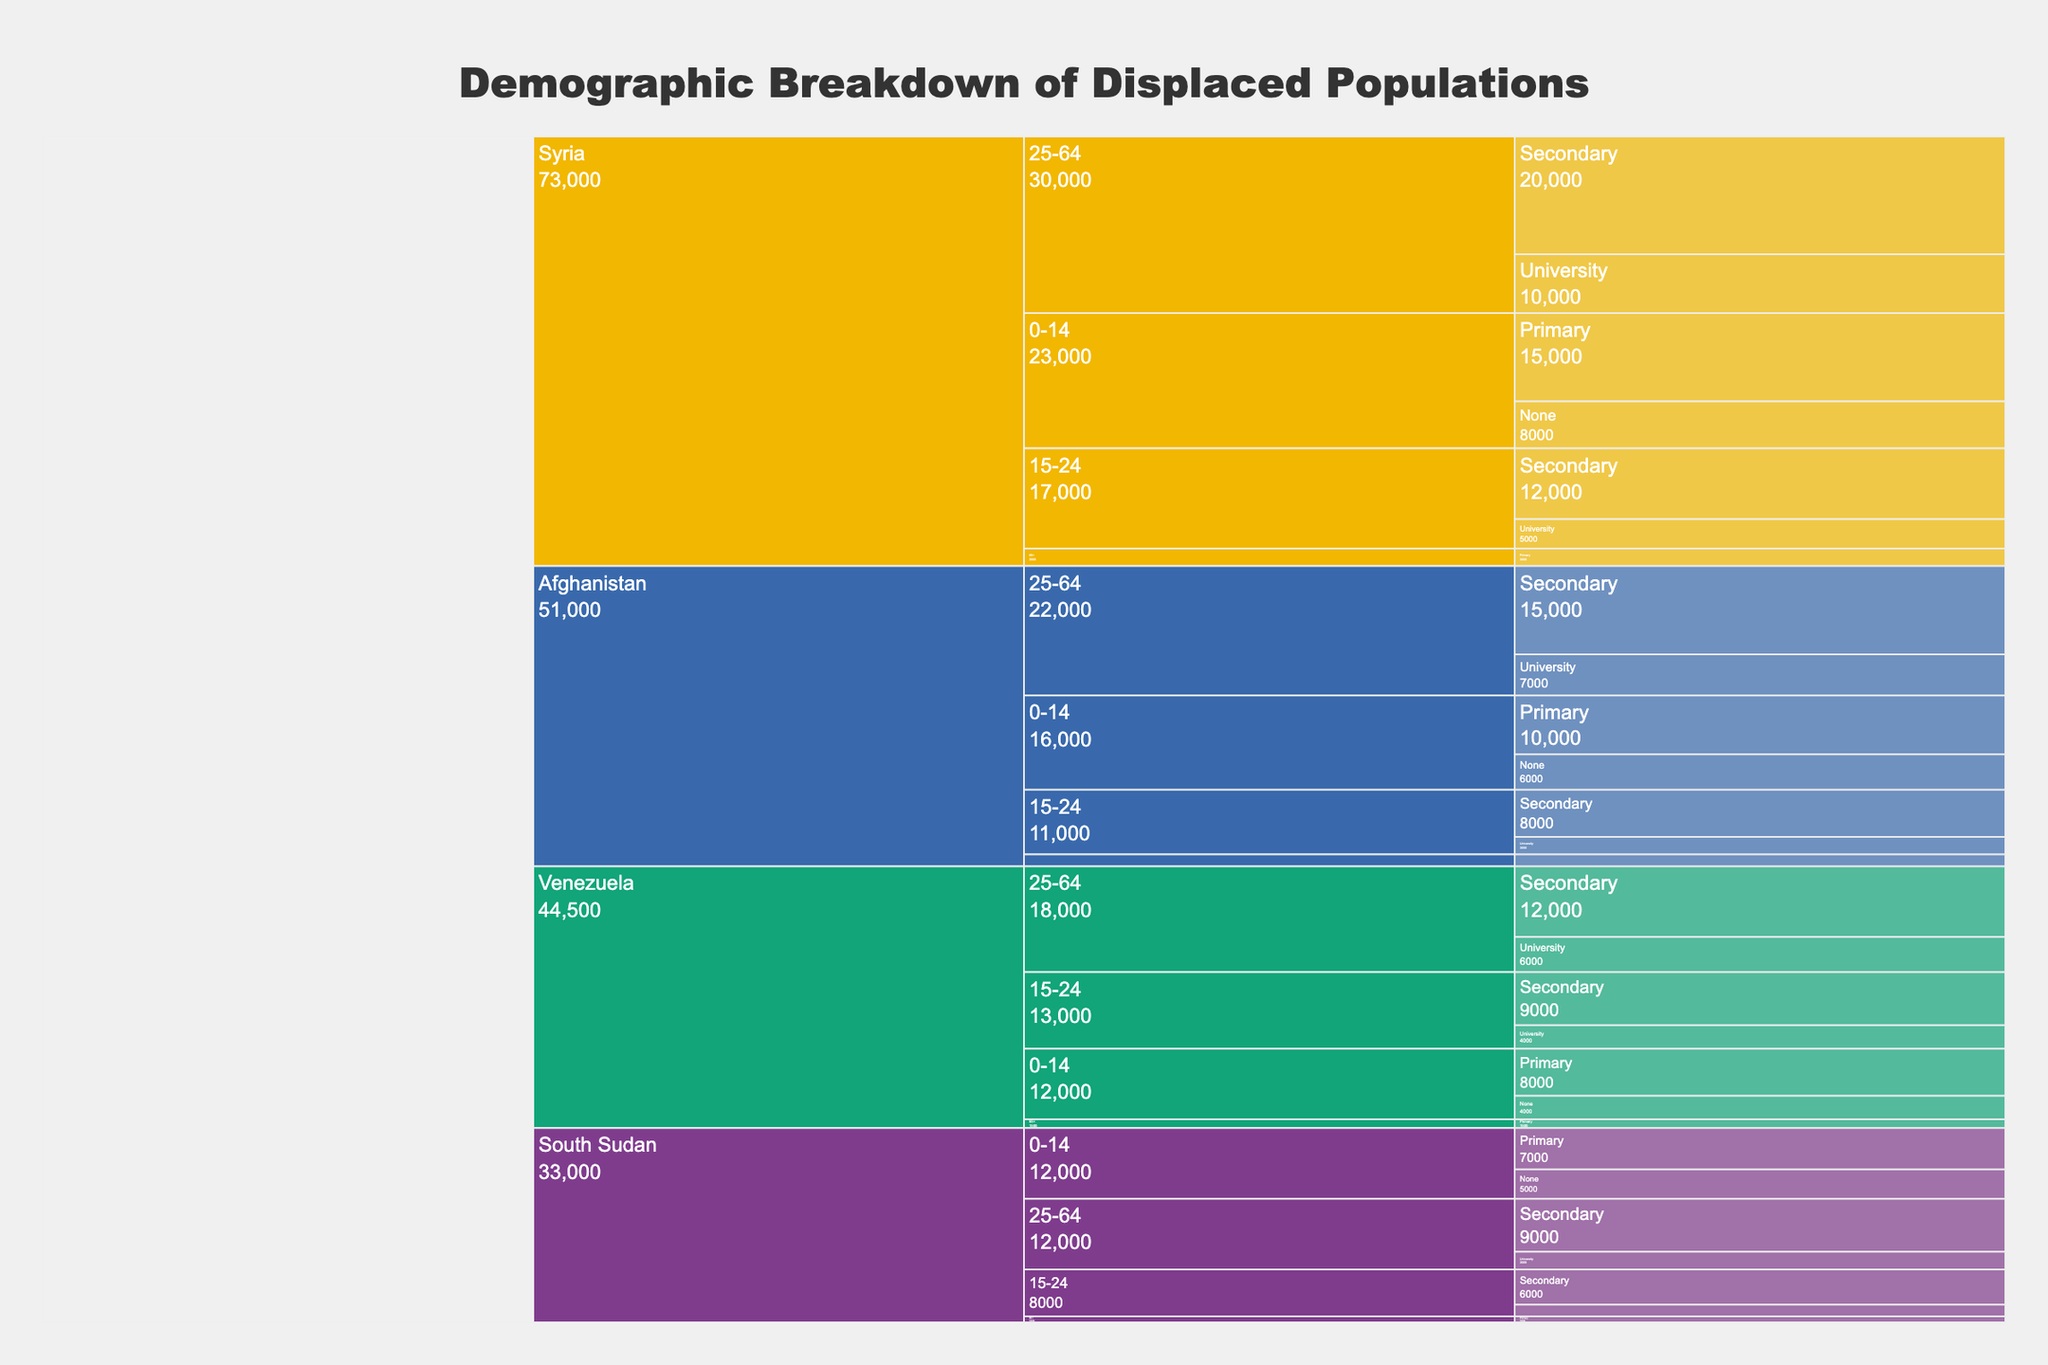What is the title of the chart? The title of the chart is typically found at the top and centrally aligned. It provides a brief description of the chart's content. Here, the title is “Demographic Breakdown of Displaced Populations”.
Answer: Demographic Breakdown of Displaced Populations How many countries are represented in the chart? The icicle chart displays different segments for each country. By counting the segments at the topmost level, we can see that there are four countries: Syria, Afghanistan, Venezuela, and South Sudan.
Answer: Four Which country has the largest population in the 25-64 age group? To find the country with the largest population in the 25-64 age group, look at the segments under each country labeled 25-64 and compare their sizes. Syria has the largest population in this age group.
Answer: Syria What is the total population of displaced people from Syria with secondary education? To find the total population with secondary education from Syria, sum the populations of the corresponding age groups. The populations are 12,000 (15-24 age group) and 20,000 (25-64 age group). 12,000 + 20,000 = 32,000.
Answer: 32,000 Which age group has the highest population of displaced people from Venezuela? By examining the branches under Venezuela, compare the sizes of each age group's segments. The 25-64 age group has the highest population.
Answer: 25-64 Compare the number of displaced people with a university education from Afghanistan and South Sudan. Which country has more? Look at the segments for the university education level under Afghanistan and South Sudan. Afghanistan has 3,000 (15-24) + 7,000 (25-64) = 10,000 and South Sudan has 2,000 (15-24) + 3,000 (25-64) = 5,000. Afghanistan has more.
Answer: Afghanistan Calculate the total number of displaced people across all countries aged 0-14 with no education. Sum the populations of the 0-14 age group with no education for all countries. Syria: 8,000, Afghanistan: 6,000, Venezuela: 4,000, South Sudan: 5,000. Total = 8,000 + 6,000 + 4,000 + 5,000 = 23,000.
Answer: 23,000 Which country has the smallest population of displaced people aged 65+? Compare the segments for the 65+ age group across all countries. South Sudan has the smallest population with 1,000.
Answer: South Sudan What percentage of the Venezuelan displaced population aged 15-24 have a university education? To calculate the percentage, divide the number of university-educated people aged 15-24 by the total population of that age group and multiply by 100. For Venezuela: 4,000 (university) / (9,000 + 4,000) = 4,000/13,000 ≈ 30.77%.
Answer: ~30.77% 